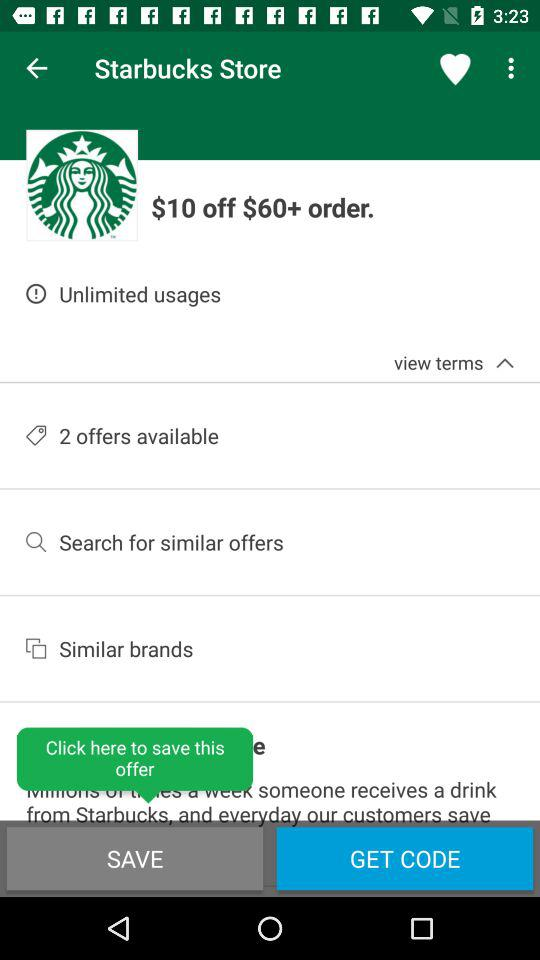How many offers are available? There are 2 offers available. 